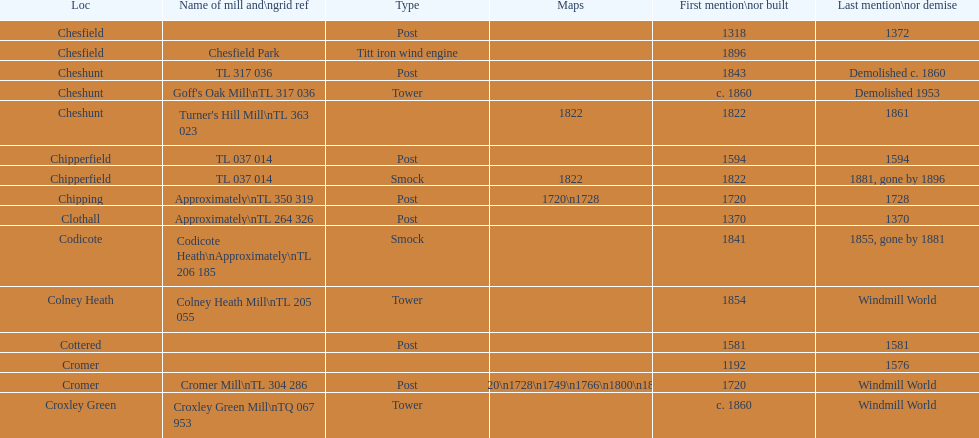What is the total number of mills named cheshunt? 3. 